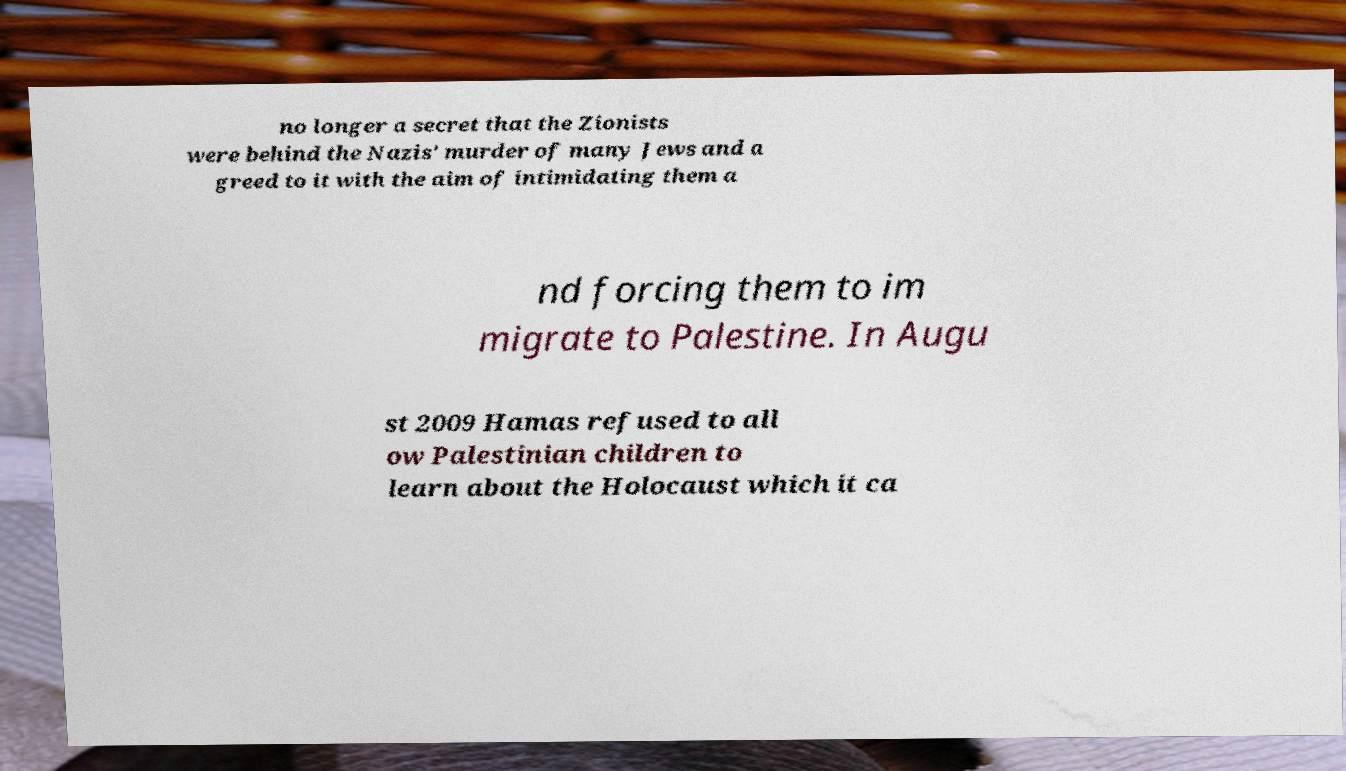There's text embedded in this image that I need extracted. Can you transcribe it verbatim? no longer a secret that the Zionists were behind the Nazis' murder of many Jews and a greed to it with the aim of intimidating them a nd forcing them to im migrate to Palestine. In Augu st 2009 Hamas refused to all ow Palestinian children to learn about the Holocaust which it ca 